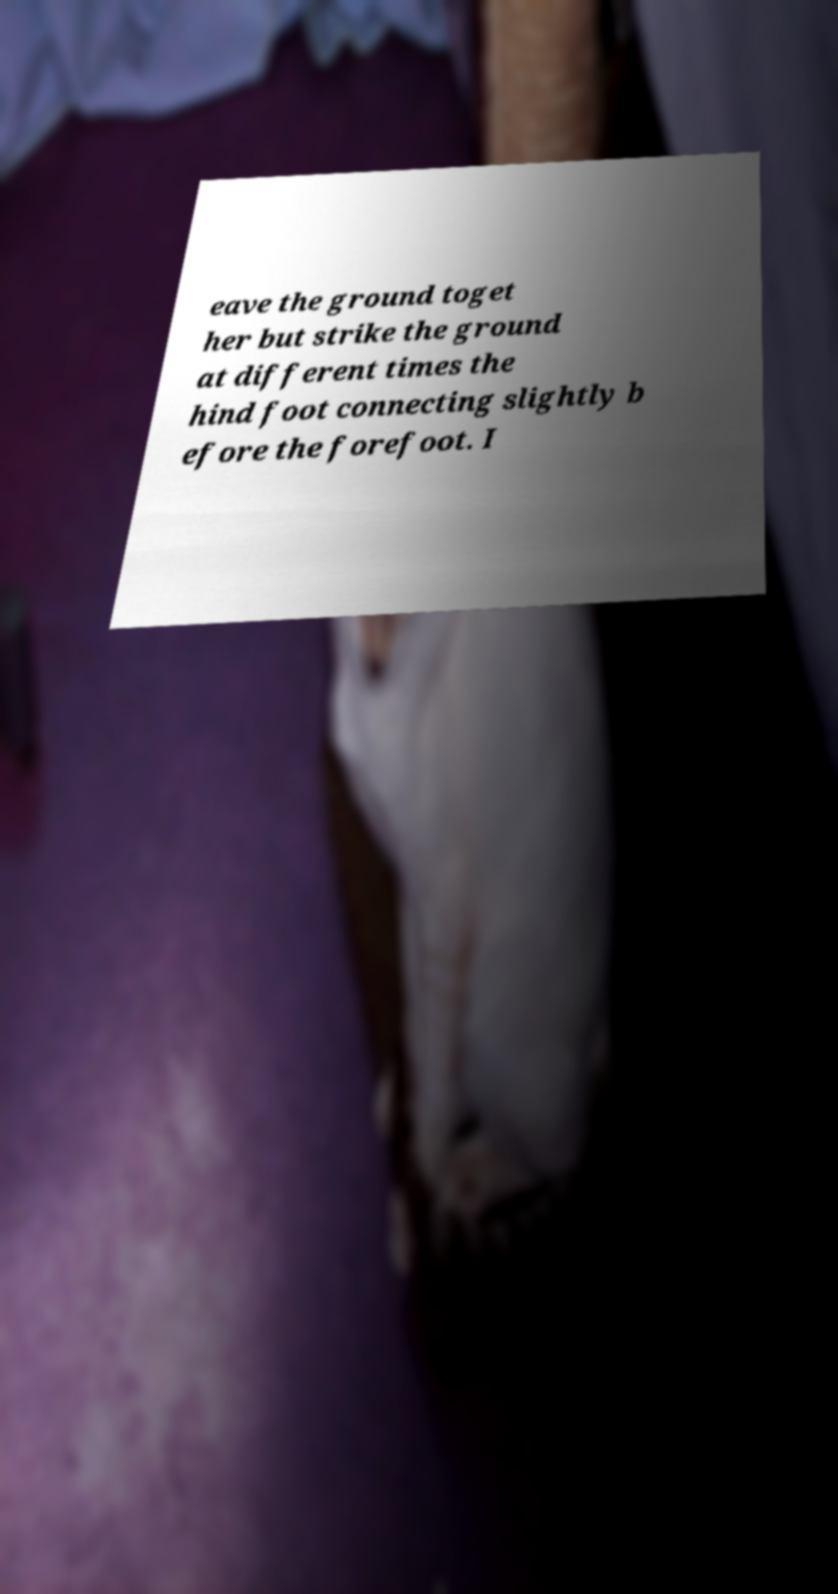There's text embedded in this image that I need extracted. Can you transcribe it verbatim? eave the ground toget her but strike the ground at different times the hind foot connecting slightly b efore the forefoot. I 